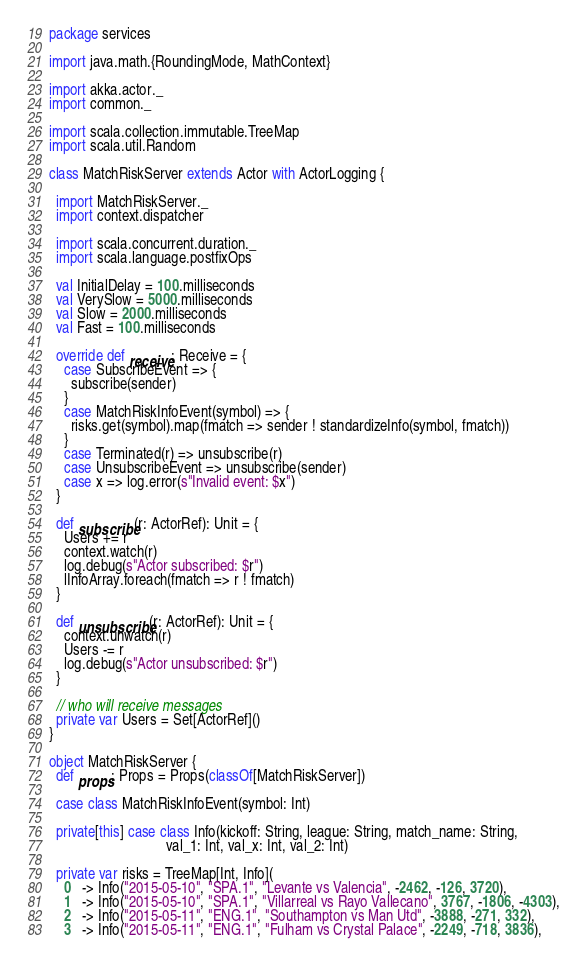Convert code to text. <code><loc_0><loc_0><loc_500><loc_500><_Scala_>package services

import java.math.{RoundingMode, MathContext}

import akka.actor._
import common._

import scala.collection.immutable.TreeMap
import scala.util.Random

class MatchRiskServer extends Actor with ActorLogging {

  import MatchRiskServer._
  import context.dispatcher

  import scala.concurrent.duration._
  import scala.language.postfixOps

  val InitialDelay = 100.milliseconds
  val VerySlow = 5000.milliseconds
  val Slow = 2000.milliseconds
  val Fast = 100.milliseconds

  override def receive: Receive = {
    case SubscribeEvent => {
      subscribe(sender)
    }
    case MatchRiskInfoEvent(symbol) => {
      risks.get(symbol).map(fmatch => sender ! standardizeInfo(symbol, fmatch))
    }
    case Terminated(r) => unsubscribe(r)
    case UnsubscribeEvent => unsubscribe(sender)
    case x => log.error(s"Invalid event: $x")
  }

  def subscribe(r: ActorRef): Unit = {
    Users += r
    context.watch(r)
    log.debug(s"Actor subscribed: $r")
    lInfoArray.foreach(fmatch => r ! fmatch)
  }

  def unsubscribe(r: ActorRef): Unit = {
    context.unwatch(r)
    Users -= r
    log.debug(s"Actor unsubscribed: $r")
  }

  // who will receive messages
  private var Users = Set[ActorRef]()
}

object MatchRiskServer {
  def props: Props = Props(classOf[MatchRiskServer])

  case class MatchRiskInfoEvent(symbol: Int)

  private[this] case class Info(kickoff: String, league: String, match_name: String,
                                val_1: Int, val_x: Int, val_2: Int)

  private var risks = TreeMap[Int, Info](
    0   -> Info("2015-05-10", "SPA.1", "Levante vs Valencia", -2462, -126, 3720),
    1   -> Info("2015-05-10", "SPA.1", "Villarreal vs Rayo Vallecano", 3767, -1806, -4303),
    2   -> Info("2015-05-11", "ENG.1", "Southampton vs Man Utd", -3888, -271, 332),
    3   -> Info("2015-05-11", "ENG.1", "Fulham vs Crystal Palace", -2249, -718, 3836),</code> 